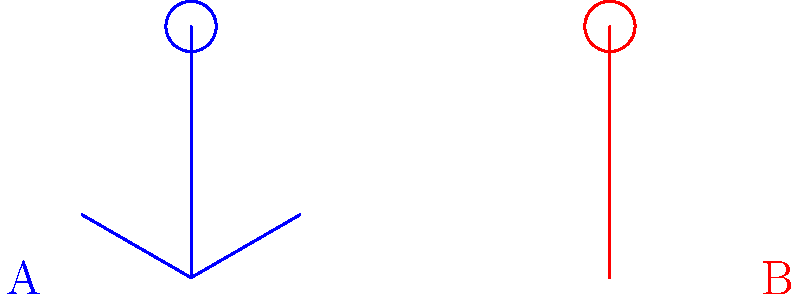Consider the two volleyball blocking positions shown in the body segment diagram above. Position A shows a blocker with arms at a 30-degree angle from the body, while Position B shows a blocker with arms fully extended at a 90-degree angle. Assuming the blocker's mass and height remain constant, how does the moment of inertia about the vertical axis through the center of mass compare between these two positions? To compare the moment of inertia between the two positions, we need to consider the distribution of mass relative to the axis of rotation. Let's break this down step-by-step:

1. Moment of inertia (I) is given by the formula $I = \sum m_i r_i^2$, where $m_i$ is the mass of each body segment and $r_i$ is the perpendicular distance from the axis of rotation to the center of mass of each segment.

2. In both positions, the mass of the body segments remains constant. The key difference is the position of the arms relative to the vertical axis through the center of mass.

3. In Position A (30-degree angle):
   - The arms are closer to the body
   - The perpendicular distance ($r$) from the vertical axis to the center of mass of the arms is relatively small

4. In Position B (90-degree angle):
   - The arms are fully extended
   - The perpendicular distance ($r$) from the vertical axis to the center of mass of the arms is at its maximum

5. Since the moment of inertia is proportional to the square of the distance ($r^2$), even a small increase in $r$ can significantly increase the moment of inertia.

6. The legs and torso contribute similarly to the moment of inertia in both positions, so the main difference comes from the arm positions.

7. Therefore, Position B will have a significantly larger moment of inertia about the vertical axis compared to Position A.

This increased moment of inertia in Position B means that the blocker will have greater rotational inertia, making it harder to initiate or stop rotation about the vertical axis, which can be advantageous in maintaining stability during a block.
Answer: Position B has a larger moment of inertia. 